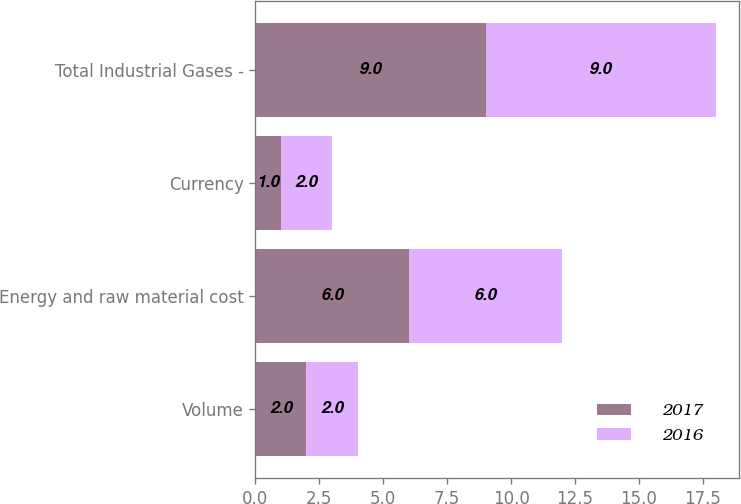Convert chart to OTSL. <chart><loc_0><loc_0><loc_500><loc_500><stacked_bar_chart><ecel><fcel>Volume<fcel>Energy and raw material cost<fcel>Currency<fcel>Total Industrial Gases -<nl><fcel>2017<fcel>2<fcel>6<fcel>1<fcel>9<nl><fcel>2016<fcel>2<fcel>6<fcel>2<fcel>9<nl></chart> 